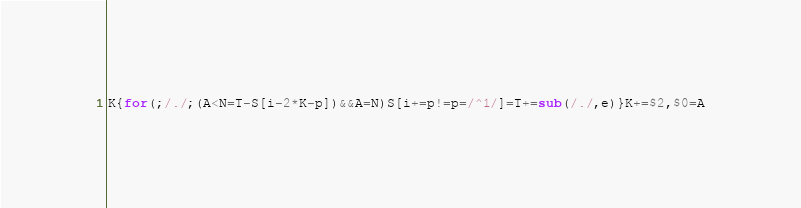<code> <loc_0><loc_0><loc_500><loc_500><_Awk_>K{for(;/./;(A<N=T-S[i-2*K-p])&&A=N)S[i+=p!=p=/^1/]=T+=sub(/./,e)}K+=$2,$0=A</code> 